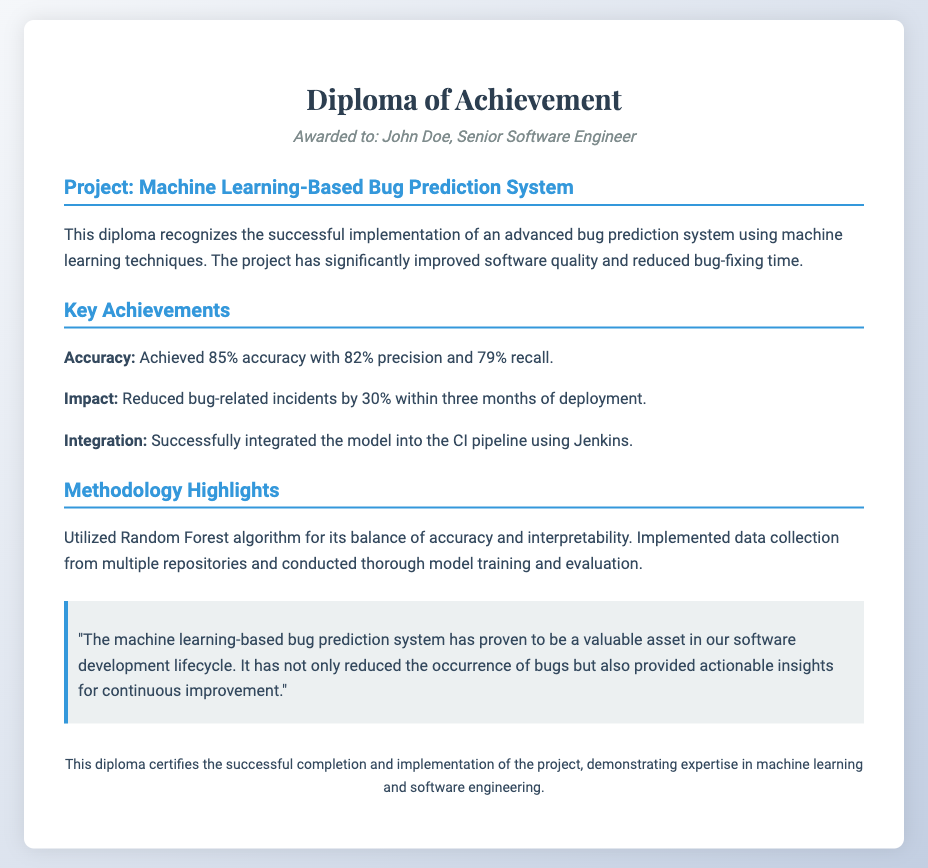What is the title of the project? The title of the project is mentioned in the document under the Project section.
Answer: Machine Learning-Based Bug Prediction System What is the accuracy achieved by the system? The accuracy is specified in the Key Achievements section of the document.
Answer: 85% Who was awarded the diploma? The recipient of the diploma is stated in the header of the document.
Answer: John Doe What is the reduction percentage of bug-related incidents? This information is found in the Key Achievements section related to the project's impact.
Answer: 30% What algorithm was utilized for the bug prediction system? The methodology highlight section provides details about the algorithm used.
Answer: Random Forest What was the precision achieved by the system? Precision is listed along with other performance metrics in the Key Achievements section.
Answer: 82% What integration tool was used for the model? This is mentioned under the Key Achievements section regarding the system's integration.
Answer: Jenkins What is the main benefit of the machine learning-based bug prediction system? The benefit is summarized in the highlight section of the document.
Answer: Valuable asset What is discussed in the Methodology Highlights section? The Methodology Highlights section outlines the key aspects of the approach taken for the project.
Answer: Data collection, model training, and evaluation 